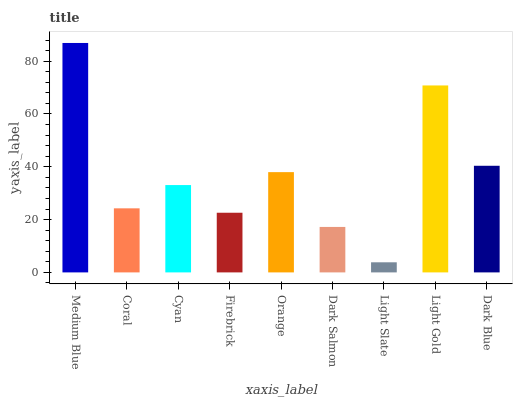Is Coral the minimum?
Answer yes or no. No. Is Coral the maximum?
Answer yes or no. No. Is Medium Blue greater than Coral?
Answer yes or no. Yes. Is Coral less than Medium Blue?
Answer yes or no. Yes. Is Coral greater than Medium Blue?
Answer yes or no. No. Is Medium Blue less than Coral?
Answer yes or no. No. Is Cyan the high median?
Answer yes or no. Yes. Is Cyan the low median?
Answer yes or no. Yes. Is Dark Salmon the high median?
Answer yes or no. No. Is Light Gold the low median?
Answer yes or no. No. 